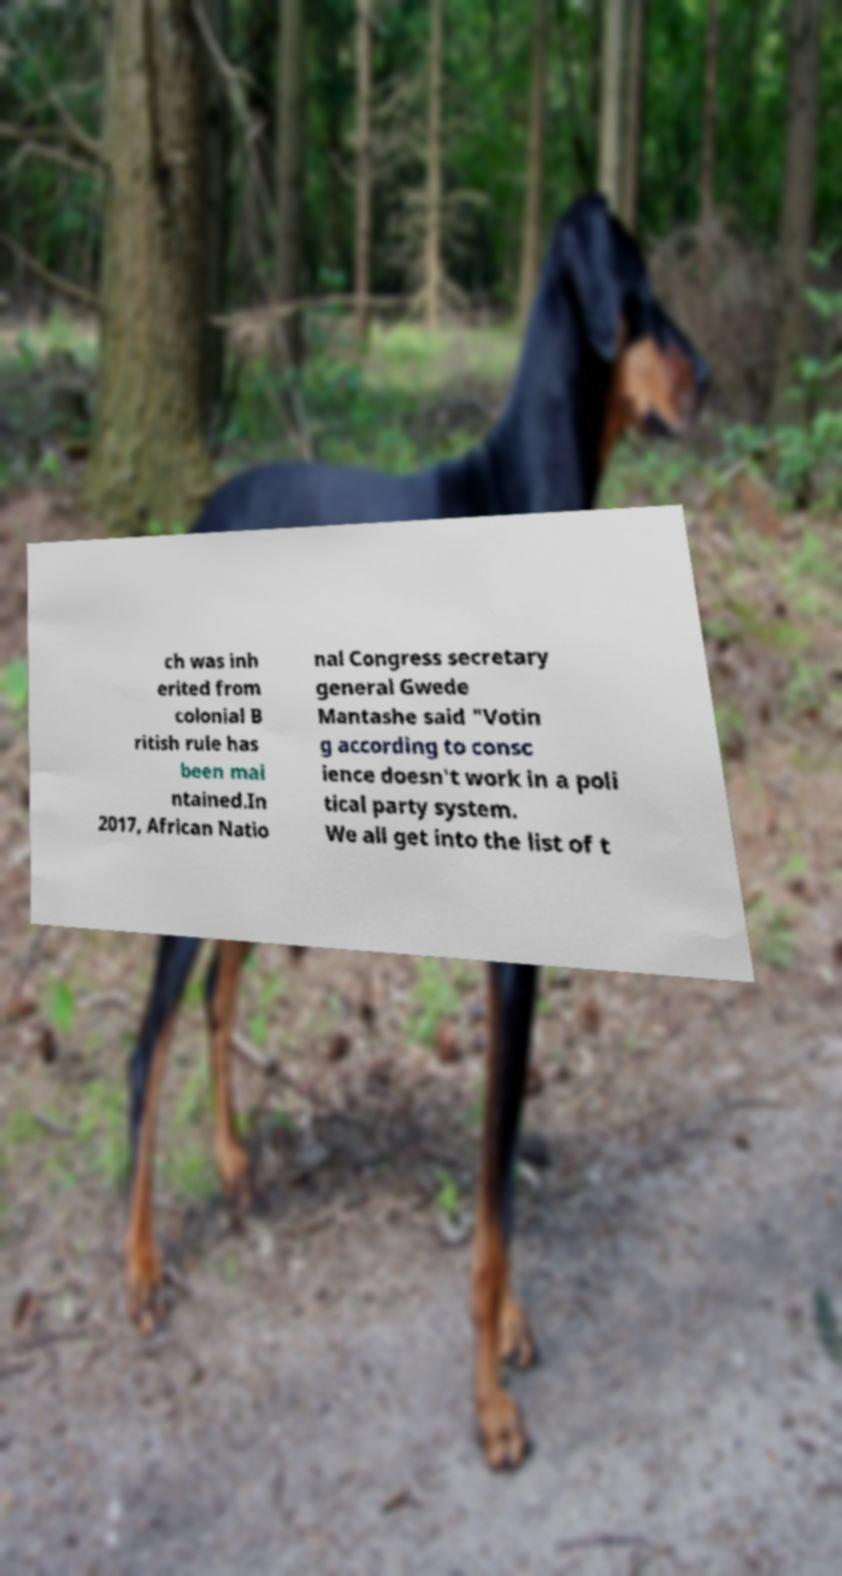I need the written content from this picture converted into text. Can you do that? ch was inh erited from colonial B ritish rule has been mai ntained.In 2017, African Natio nal Congress secretary general Gwede Mantashe said "Votin g according to consc ience doesn't work in a poli tical party system. We all get into the list of t 